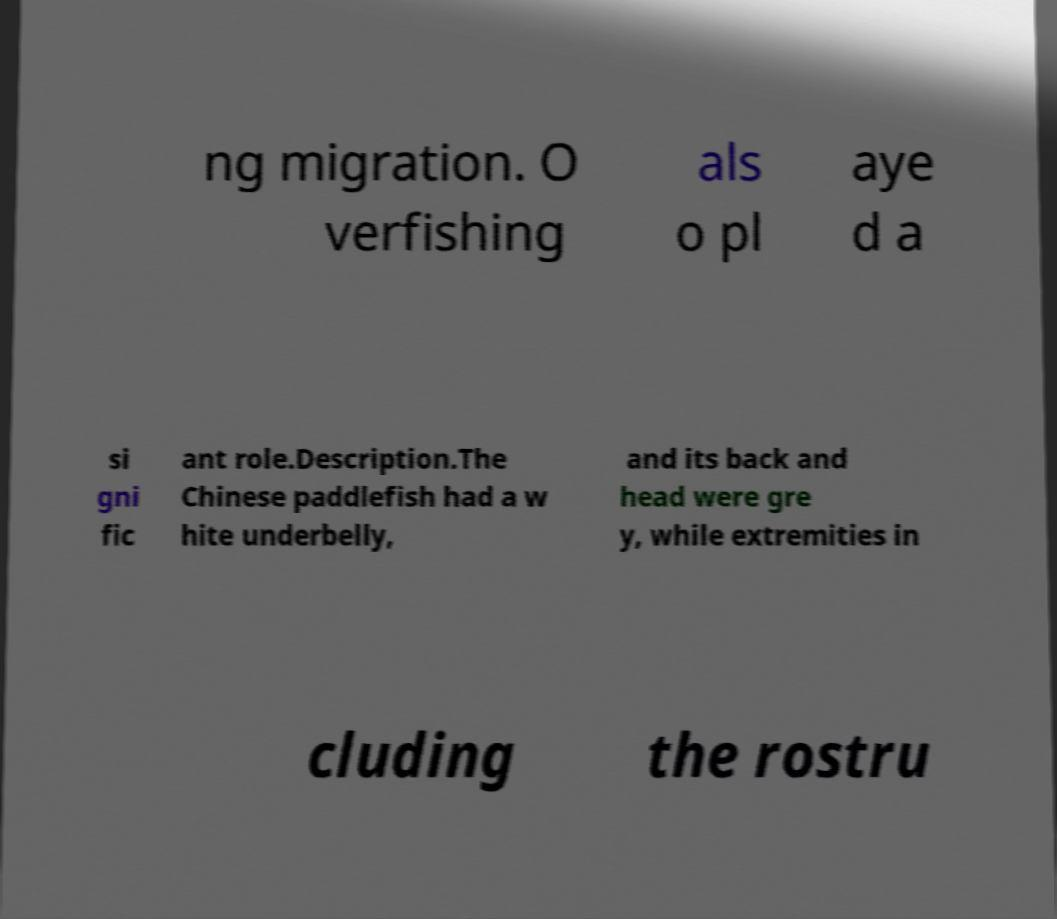Please identify and transcribe the text found in this image. ng migration. O verfishing als o pl aye d a si gni fic ant role.Description.The Chinese paddlefish had a w hite underbelly, and its back and head were gre y, while extremities in cluding the rostru 